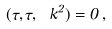<formula> <loc_0><loc_0><loc_500><loc_500>\Omega ( \tau , \tau , \ k ^ { 2 } ) = 0 \, ,</formula> 